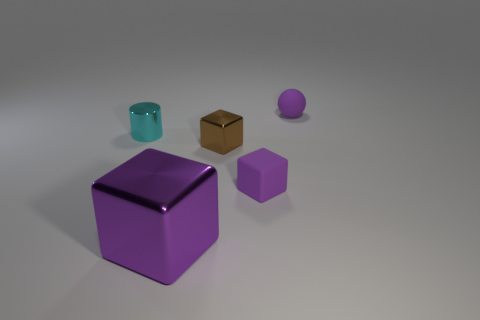Add 1 rubber blocks. How many objects exist? 6 Subtract all blocks. How many objects are left? 2 Subtract 0 gray spheres. How many objects are left? 5 Subtract all large blocks. Subtract all tiny objects. How many objects are left? 0 Add 1 tiny matte cubes. How many tiny matte cubes are left? 2 Add 2 blue things. How many blue things exist? 2 